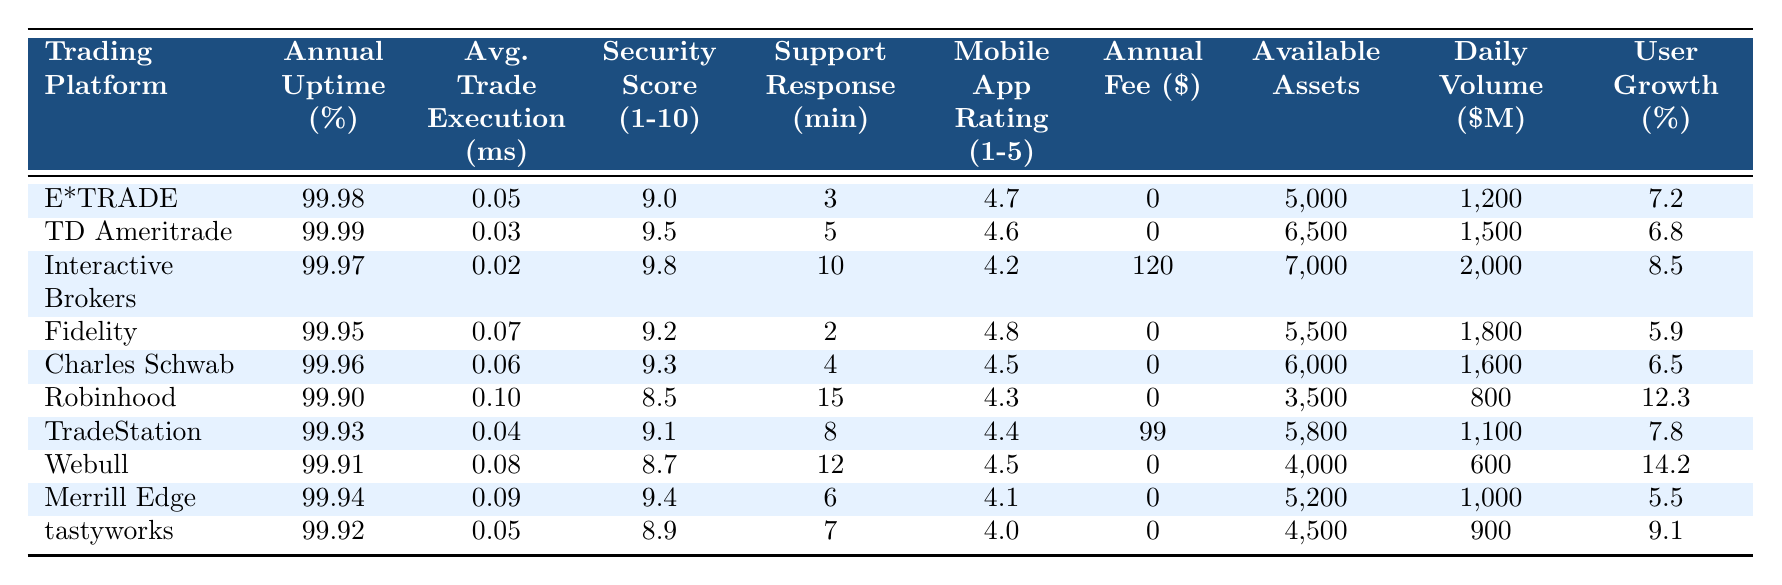What is the average annual uptime across all trading platforms? To find the average annual uptime, sum the annual uptime percentages of all platforms and divide by the number of platforms. (99.98 + 99.99 + 99.97 + 99.95 + 99.96 + 99.90 + 99.93 + 99.91 + 99.94 + 99.92) = 999.81. There are 10 platforms, so the average is 999.81 / 10 = 99.981%.
Answer: 99.981% Which platform has the highest security score? By reviewing the security scores in the table, Interactive Brokers has the highest score at 9.8.
Answer: Interactive Brokers What is the difference in average trade execution time between TD Ameritrade and Robinhood? The average trade execution time for TD Ameritrade is 0.03 ms and for Robinhood is 0.10 ms. The difference is 0.10 - 0.03 = 0.07 ms.
Answer: 0.07 ms Does any platform charge an annual fee? From the table, Robinhood, TradeStation, and Interactive Brokers are the only platforms with an annual fee: 0, 99, and 120 respectively. Therefore, there are platforms that charge fees.
Answer: Yes Which platform has the fastest average trade execution time and what is it? By comparing the average trade execution times, Interactive Brokers has the fastest at 0.02 ms.
Answer: Interactive Brokers, 0.02 ms What is the total number of available assets across all platforms? To find the total number of available assets, sum the values: (5000 + 6500 + 7000 + 5500 + 6000 + 3500 + 5800 + 4000 + 5200 + 4500) = 45,300 assets.
Answer: 45,300 assets What percentage growth does Robinhood experience compared to Charles Schwab? To find the percentage difference, subtract Charles Schwab's growth rate from Robinhood's: 12.3 - 6.5 = 5.8%. This shows Robinhood's growth rate is 5.8% higher than Charles Schwab's.
Answer: 5.8% Is the mobile app rating for Fidelity higher than that for Charles Schwab? Fidelity has a mobile app rating of 4.8, while Charles Schwab has 4.5. Since 4.8 is greater than 4.5, Fidelity's rating is higher.
Answer: Yes What is the average daily trading volume among all platforms? To calculate the average daily trading volume, sum the daily volumes: (1200 + 1500 + 2000 + 1800 + 1600 + 800 + 1100 + 600 + 1000 + 900) = 12,700. Then divide by 10 platforms: 12,700 / 10 = 1270.
Answer: 1270 Which trading platform has the lowest customer support response time? Upon examining the customer support response times, Fidelity has the lowest response time of 2 minutes.
Answer: Fidelity, 2 minutes 